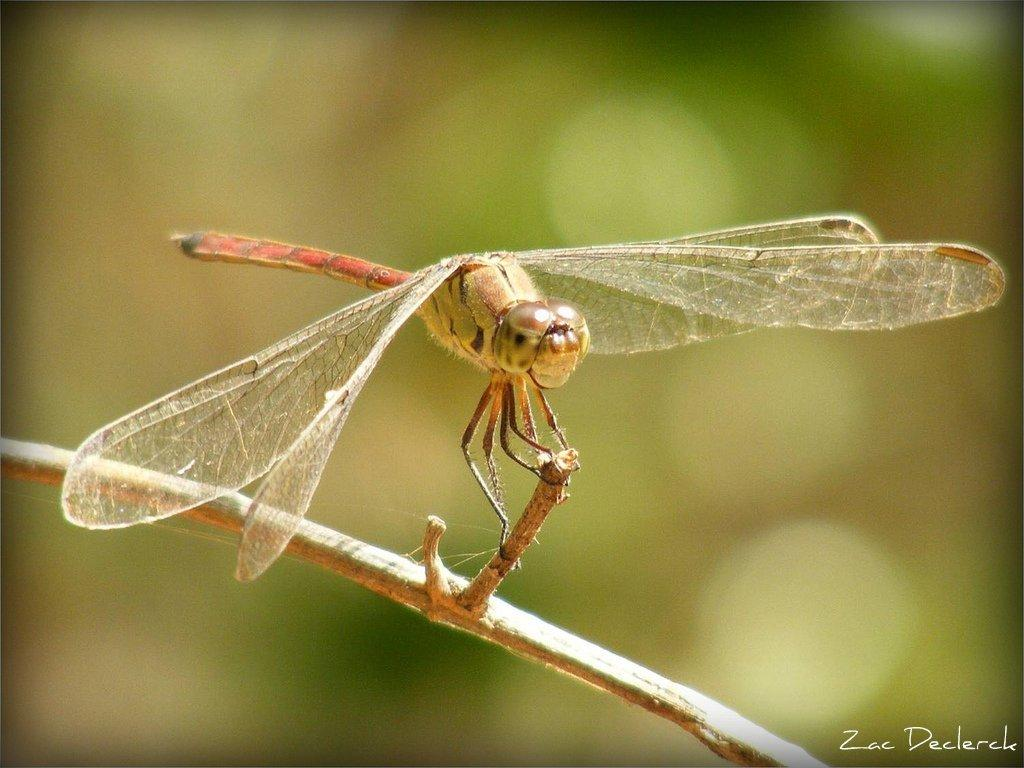What type of creature is in the image? There is an insect in the image. Where is the insect located? The insect is on a stem. What feature does the insect have? The insect has wings. Can you describe the background of the image? The background of the image is blurry. What type of record does the insect hold in its hands in the image? There is no record present in the image, and insects do not have hands. 